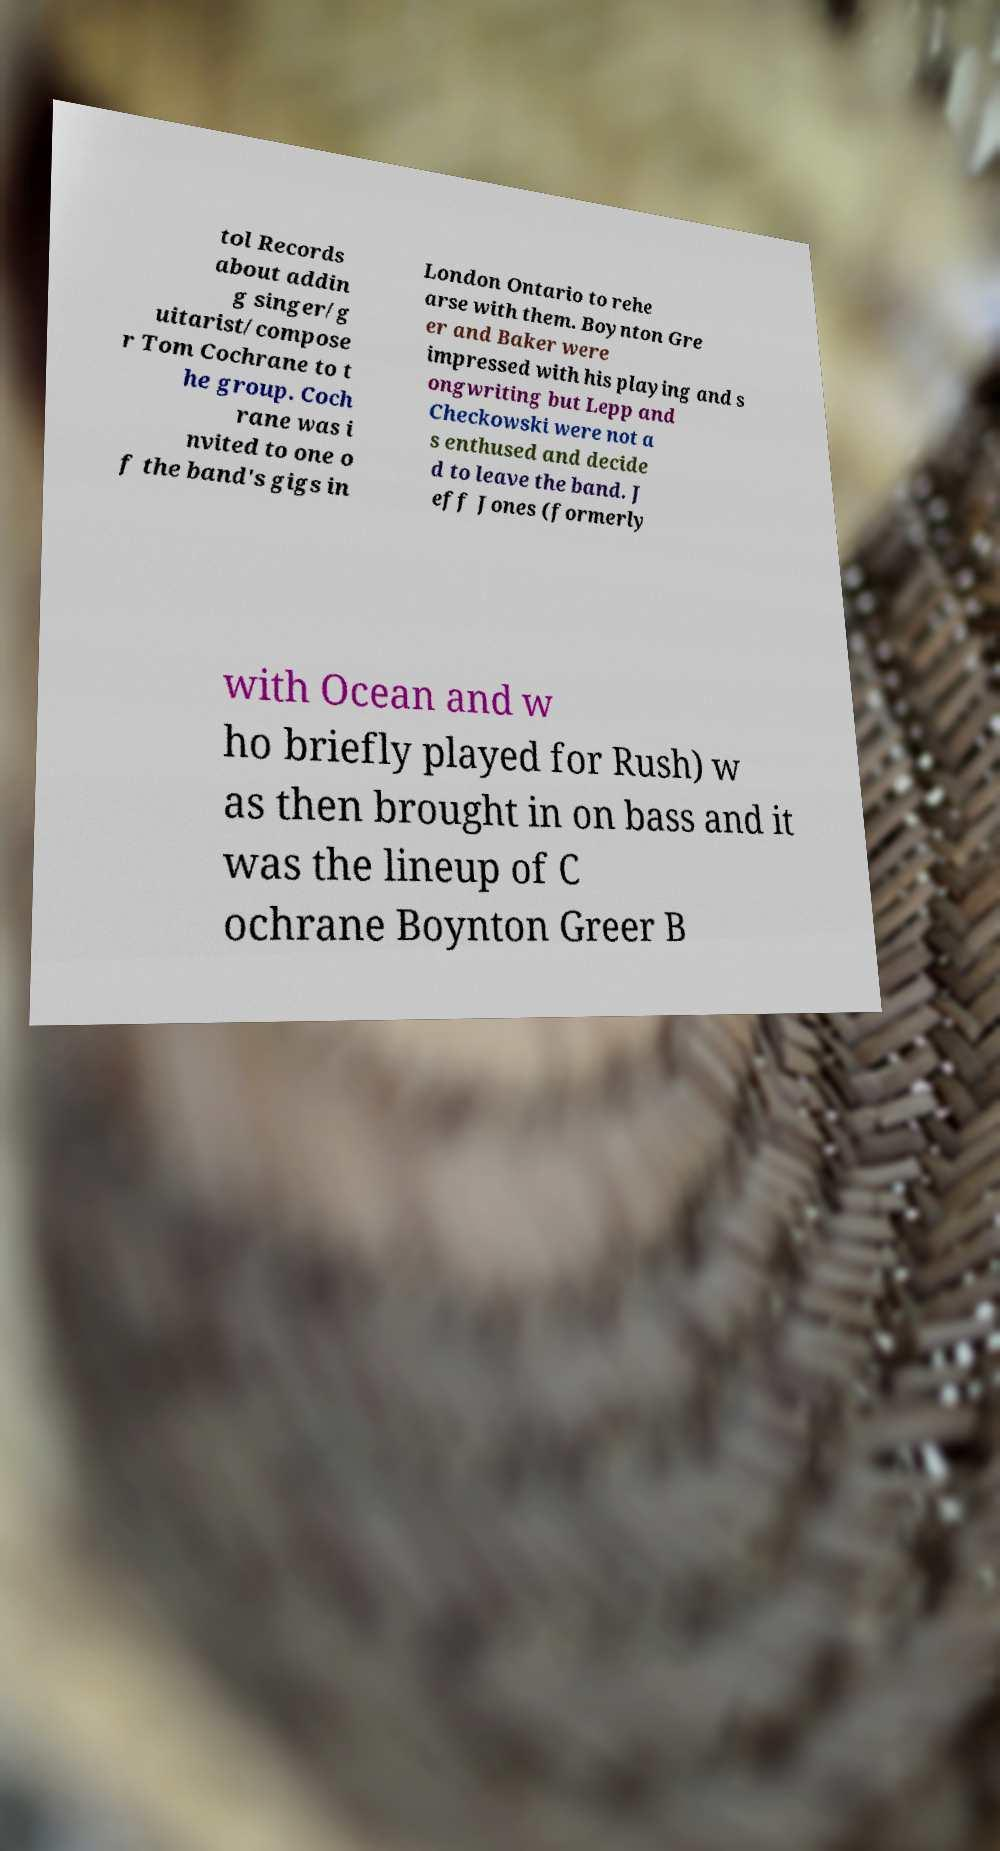What messages or text are displayed in this image? I need them in a readable, typed format. tol Records about addin g singer/g uitarist/compose r Tom Cochrane to t he group. Coch rane was i nvited to one o f the band's gigs in London Ontario to rehe arse with them. Boynton Gre er and Baker were impressed with his playing and s ongwriting but Lepp and Checkowski were not a s enthused and decide d to leave the band. J eff Jones (formerly with Ocean and w ho briefly played for Rush) w as then brought in on bass and it was the lineup of C ochrane Boynton Greer B 